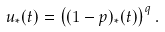Convert formula to latex. <formula><loc_0><loc_0><loc_500><loc_500>u _ { \ast \L } ( t ) = \left ( ( 1 - p ) \L _ { \ast } ( t ) \right ) ^ { q } .</formula> 